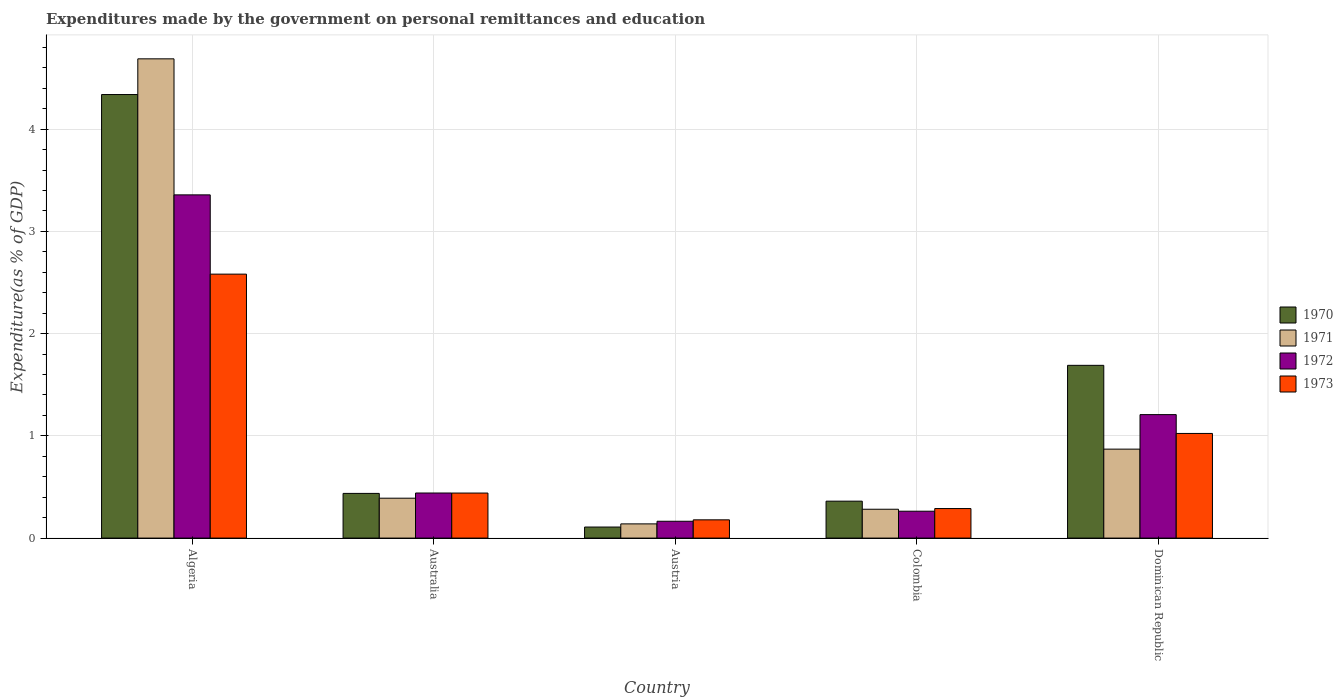Are the number of bars per tick equal to the number of legend labels?
Your answer should be very brief. Yes. How many bars are there on the 3rd tick from the left?
Offer a terse response. 4. How many bars are there on the 2nd tick from the right?
Offer a very short reply. 4. What is the label of the 5th group of bars from the left?
Make the answer very short. Dominican Republic. What is the expenditures made by the government on personal remittances and education in 1973 in Colombia?
Your answer should be very brief. 0.29. Across all countries, what is the maximum expenditures made by the government on personal remittances and education in 1970?
Ensure brevity in your answer.  4.34. Across all countries, what is the minimum expenditures made by the government on personal remittances and education in 1971?
Your answer should be very brief. 0.14. In which country was the expenditures made by the government on personal remittances and education in 1972 maximum?
Your answer should be very brief. Algeria. What is the total expenditures made by the government on personal remittances and education in 1972 in the graph?
Ensure brevity in your answer.  5.43. What is the difference between the expenditures made by the government on personal remittances and education in 1973 in Algeria and that in Australia?
Your answer should be compact. 2.14. What is the difference between the expenditures made by the government on personal remittances and education in 1971 in Dominican Republic and the expenditures made by the government on personal remittances and education in 1970 in Algeria?
Ensure brevity in your answer.  -3.47. What is the average expenditures made by the government on personal remittances and education in 1973 per country?
Keep it short and to the point. 0.9. What is the difference between the expenditures made by the government on personal remittances and education of/in 1972 and expenditures made by the government on personal remittances and education of/in 1970 in Colombia?
Offer a very short reply. -0.1. In how many countries, is the expenditures made by the government on personal remittances and education in 1973 greater than 0.4 %?
Your answer should be compact. 3. What is the ratio of the expenditures made by the government on personal remittances and education in 1973 in Algeria to that in Australia?
Offer a terse response. 5.86. What is the difference between the highest and the second highest expenditures made by the government on personal remittances and education in 1970?
Keep it short and to the point. -1.25. What is the difference between the highest and the lowest expenditures made by the government on personal remittances and education in 1970?
Keep it short and to the point. 4.23. In how many countries, is the expenditures made by the government on personal remittances and education in 1970 greater than the average expenditures made by the government on personal remittances and education in 1970 taken over all countries?
Offer a very short reply. 2. Is it the case that in every country, the sum of the expenditures made by the government on personal remittances and education in 1970 and expenditures made by the government on personal remittances and education in 1973 is greater than the sum of expenditures made by the government on personal remittances and education in 1971 and expenditures made by the government on personal remittances and education in 1972?
Your answer should be very brief. No. What does the 4th bar from the left in Colombia represents?
Offer a very short reply. 1973. Is it the case that in every country, the sum of the expenditures made by the government on personal remittances and education in 1973 and expenditures made by the government on personal remittances and education in 1972 is greater than the expenditures made by the government on personal remittances and education in 1970?
Your response must be concise. Yes. How many bars are there?
Ensure brevity in your answer.  20. Are all the bars in the graph horizontal?
Make the answer very short. No. How many countries are there in the graph?
Provide a succinct answer. 5. What is the difference between two consecutive major ticks on the Y-axis?
Give a very brief answer. 1. Are the values on the major ticks of Y-axis written in scientific E-notation?
Your response must be concise. No. Does the graph contain any zero values?
Provide a short and direct response. No. How many legend labels are there?
Ensure brevity in your answer.  4. How are the legend labels stacked?
Offer a terse response. Vertical. What is the title of the graph?
Provide a short and direct response. Expenditures made by the government on personal remittances and education. What is the label or title of the Y-axis?
Your answer should be compact. Expenditure(as % of GDP). What is the Expenditure(as % of GDP) of 1970 in Algeria?
Provide a succinct answer. 4.34. What is the Expenditure(as % of GDP) in 1971 in Algeria?
Ensure brevity in your answer.  4.69. What is the Expenditure(as % of GDP) in 1972 in Algeria?
Provide a short and direct response. 3.36. What is the Expenditure(as % of GDP) in 1973 in Algeria?
Keep it short and to the point. 2.58. What is the Expenditure(as % of GDP) of 1970 in Australia?
Offer a terse response. 0.44. What is the Expenditure(as % of GDP) in 1971 in Australia?
Your answer should be compact. 0.39. What is the Expenditure(as % of GDP) in 1972 in Australia?
Provide a succinct answer. 0.44. What is the Expenditure(as % of GDP) of 1973 in Australia?
Your answer should be very brief. 0.44. What is the Expenditure(as % of GDP) in 1970 in Austria?
Offer a very short reply. 0.11. What is the Expenditure(as % of GDP) of 1971 in Austria?
Make the answer very short. 0.14. What is the Expenditure(as % of GDP) in 1972 in Austria?
Make the answer very short. 0.16. What is the Expenditure(as % of GDP) in 1973 in Austria?
Provide a short and direct response. 0.18. What is the Expenditure(as % of GDP) of 1970 in Colombia?
Offer a terse response. 0.36. What is the Expenditure(as % of GDP) of 1971 in Colombia?
Your answer should be very brief. 0.28. What is the Expenditure(as % of GDP) of 1972 in Colombia?
Ensure brevity in your answer.  0.26. What is the Expenditure(as % of GDP) in 1973 in Colombia?
Your response must be concise. 0.29. What is the Expenditure(as % of GDP) in 1970 in Dominican Republic?
Provide a succinct answer. 1.69. What is the Expenditure(as % of GDP) of 1971 in Dominican Republic?
Your response must be concise. 0.87. What is the Expenditure(as % of GDP) in 1972 in Dominican Republic?
Ensure brevity in your answer.  1.21. What is the Expenditure(as % of GDP) of 1973 in Dominican Republic?
Your answer should be very brief. 1.02. Across all countries, what is the maximum Expenditure(as % of GDP) in 1970?
Your response must be concise. 4.34. Across all countries, what is the maximum Expenditure(as % of GDP) in 1971?
Your answer should be very brief. 4.69. Across all countries, what is the maximum Expenditure(as % of GDP) of 1972?
Your response must be concise. 3.36. Across all countries, what is the maximum Expenditure(as % of GDP) in 1973?
Keep it short and to the point. 2.58. Across all countries, what is the minimum Expenditure(as % of GDP) of 1970?
Ensure brevity in your answer.  0.11. Across all countries, what is the minimum Expenditure(as % of GDP) of 1971?
Give a very brief answer. 0.14. Across all countries, what is the minimum Expenditure(as % of GDP) of 1972?
Ensure brevity in your answer.  0.16. Across all countries, what is the minimum Expenditure(as % of GDP) in 1973?
Make the answer very short. 0.18. What is the total Expenditure(as % of GDP) in 1970 in the graph?
Your answer should be very brief. 6.93. What is the total Expenditure(as % of GDP) of 1971 in the graph?
Offer a very short reply. 6.37. What is the total Expenditure(as % of GDP) of 1972 in the graph?
Your response must be concise. 5.43. What is the total Expenditure(as % of GDP) of 1973 in the graph?
Provide a short and direct response. 4.51. What is the difference between the Expenditure(as % of GDP) of 1970 in Algeria and that in Australia?
Make the answer very short. 3.9. What is the difference between the Expenditure(as % of GDP) in 1971 in Algeria and that in Australia?
Offer a terse response. 4.3. What is the difference between the Expenditure(as % of GDP) of 1972 in Algeria and that in Australia?
Give a very brief answer. 2.92. What is the difference between the Expenditure(as % of GDP) of 1973 in Algeria and that in Australia?
Offer a terse response. 2.14. What is the difference between the Expenditure(as % of GDP) of 1970 in Algeria and that in Austria?
Your answer should be compact. 4.23. What is the difference between the Expenditure(as % of GDP) of 1971 in Algeria and that in Austria?
Your answer should be very brief. 4.55. What is the difference between the Expenditure(as % of GDP) in 1972 in Algeria and that in Austria?
Offer a terse response. 3.19. What is the difference between the Expenditure(as % of GDP) of 1973 in Algeria and that in Austria?
Your answer should be compact. 2.4. What is the difference between the Expenditure(as % of GDP) in 1970 in Algeria and that in Colombia?
Keep it short and to the point. 3.98. What is the difference between the Expenditure(as % of GDP) in 1971 in Algeria and that in Colombia?
Ensure brevity in your answer.  4.41. What is the difference between the Expenditure(as % of GDP) of 1972 in Algeria and that in Colombia?
Your answer should be very brief. 3.09. What is the difference between the Expenditure(as % of GDP) of 1973 in Algeria and that in Colombia?
Your answer should be compact. 2.29. What is the difference between the Expenditure(as % of GDP) of 1970 in Algeria and that in Dominican Republic?
Provide a succinct answer. 2.65. What is the difference between the Expenditure(as % of GDP) in 1971 in Algeria and that in Dominican Republic?
Offer a terse response. 3.82. What is the difference between the Expenditure(as % of GDP) in 1972 in Algeria and that in Dominican Republic?
Provide a succinct answer. 2.15. What is the difference between the Expenditure(as % of GDP) of 1973 in Algeria and that in Dominican Republic?
Your answer should be compact. 1.56. What is the difference between the Expenditure(as % of GDP) in 1970 in Australia and that in Austria?
Provide a short and direct response. 0.33. What is the difference between the Expenditure(as % of GDP) in 1971 in Australia and that in Austria?
Offer a very short reply. 0.25. What is the difference between the Expenditure(as % of GDP) in 1972 in Australia and that in Austria?
Offer a very short reply. 0.28. What is the difference between the Expenditure(as % of GDP) of 1973 in Australia and that in Austria?
Keep it short and to the point. 0.26. What is the difference between the Expenditure(as % of GDP) of 1970 in Australia and that in Colombia?
Provide a short and direct response. 0.08. What is the difference between the Expenditure(as % of GDP) of 1971 in Australia and that in Colombia?
Make the answer very short. 0.11. What is the difference between the Expenditure(as % of GDP) of 1972 in Australia and that in Colombia?
Provide a succinct answer. 0.18. What is the difference between the Expenditure(as % of GDP) of 1973 in Australia and that in Colombia?
Keep it short and to the point. 0.15. What is the difference between the Expenditure(as % of GDP) in 1970 in Australia and that in Dominican Republic?
Your answer should be very brief. -1.25. What is the difference between the Expenditure(as % of GDP) in 1971 in Australia and that in Dominican Republic?
Your response must be concise. -0.48. What is the difference between the Expenditure(as % of GDP) of 1972 in Australia and that in Dominican Republic?
Offer a very short reply. -0.77. What is the difference between the Expenditure(as % of GDP) of 1973 in Australia and that in Dominican Republic?
Make the answer very short. -0.58. What is the difference between the Expenditure(as % of GDP) of 1970 in Austria and that in Colombia?
Your answer should be compact. -0.25. What is the difference between the Expenditure(as % of GDP) in 1971 in Austria and that in Colombia?
Offer a terse response. -0.14. What is the difference between the Expenditure(as % of GDP) of 1972 in Austria and that in Colombia?
Offer a terse response. -0.1. What is the difference between the Expenditure(as % of GDP) of 1973 in Austria and that in Colombia?
Your response must be concise. -0.11. What is the difference between the Expenditure(as % of GDP) of 1970 in Austria and that in Dominican Republic?
Your answer should be very brief. -1.58. What is the difference between the Expenditure(as % of GDP) of 1971 in Austria and that in Dominican Republic?
Offer a very short reply. -0.73. What is the difference between the Expenditure(as % of GDP) in 1972 in Austria and that in Dominican Republic?
Your response must be concise. -1.04. What is the difference between the Expenditure(as % of GDP) of 1973 in Austria and that in Dominican Republic?
Provide a short and direct response. -0.84. What is the difference between the Expenditure(as % of GDP) of 1970 in Colombia and that in Dominican Republic?
Offer a terse response. -1.33. What is the difference between the Expenditure(as % of GDP) in 1971 in Colombia and that in Dominican Republic?
Your answer should be very brief. -0.59. What is the difference between the Expenditure(as % of GDP) in 1972 in Colombia and that in Dominican Republic?
Provide a succinct answer. -0.94. What is the difference between the Expenditure(as % of GDP) in 1973 in Colombia and that in Dominican Republic?
Keep it short and to the point. -0.73. What is the difference between the Expenditure(as % of GDP) of 1970 in Algeria and the Expenditure(as % of GDP) of 1971 in Australia?
Offer a terse response. 3.95. What is the difference between the Expenditure(as % of GDP) of 1970 in Algeria and the Expenditure(as % of GDP) of 1972 in Australia?
Your answer should be compact. 3.9. What is the difference between the Expenditure(as % of GDP) in 1970 in Algeria and the Expenditure(as % of GDP) in 1973 in Australia?
Make the answer very short. 3.9. What is the difference between the Expenditure(as % of GDP) of 1971 in Algeria and the Expenditure(as % of GDP) of 1972 in Australia?
Offer a very short reply. 4.25. What is the difference between the Expenditure(as % of GDP) of 1971 in Algeria and the Expenditure(as % of GDP) of 1973 in Australia?
Provide a succinct answer. 4.25. What is the difference between the Expenditure(as % of GDP) of 1972 in Algeria and the Expenditure(as % of GDP) of 1973 in Australia?
Your response must be concise. 2.92. What is the difference between the Expenditure(as % of GDP) in 1970 in Algeria and the Expenditure(as % of GDP) in 1971 in Austria?
Give a very brief answer. 4.2. What is the difference between the Expenditure(as % of GDP) in 1970 in Algeria and the Expenditure(as % of GDP) in 1972 in Austria?
Your answer should be compact. 4.17. What is the difference between the Expenditure(as % of GDP) in 1970 in Algeria and the Expenditure(as % of GDP) in 1973 in Austria?
Ensure brevity in your answer.  4.16. What is the difference between the Expenditure(as % of GDP) in 1971 in Algeria and the Expenditure(as % of GDP) in 1972 in Austria?
Offer a terse response. 4.52. What is the difference between the Expenditure(as % of GDP) of 1971 in Algeria and the Expenditure(as % of GDP) of 1973 in Austria?
Ensure brevity in your answer.  4.51. What is the difference between the Expenditure(as % of GDP) in 1972 in Algeria and the Expenditure(as % of GDP) in 1973 in Austria?
Give a very brief answer. 3.18. What is the difference between the Expenditure(as % of GDP) of 1970 in Algeria and the Expenditure(as % of GDP) of 1971 in Colombia?
Your answer should be very brief. 4.06. What is the difference between the Expenditure(as % of GDP) of 1970 in Algeria and the Expenditure(as % of GDP) of 1972 in Colombia?
Make the answer very short. 4.08. What is the difference between the Expenditure(as % of GDP) of 1970 in Algeria and the Expenditure(as % of GDP) of 1973 in Colombia?
Your response must be concise. 4.05. What is the difference between the Expenditure(as % of GDP) of 1971 in Algeria and the Expenditure(as % of GDP) of 1972 in Colombia?
Ensure brevity in your answer.  4.42. What is the difference between the Expenditure(as % of GDP) in 1971 in Algeria and the Expenditure(as % of GDP) in 1973 in Colombia?
Your answer should be very brief. 4.4. What is the difference between the Expenditure(as % of GDP) in 1972 in Algeria and the Expenditure(as % of GDP) in 1973 in Colombia?
Your response must be concise. 3.07. What is the difference between the Expenditure(as % of GDP) of 1970 in Algeria and the Expenditure(as % of GDP) of 1971 in Dominican Republic?
Keep it short and to the point. 3.47. What is the difference between the Expenditure(as % of GDP) of 1970 in Algeria and the Expenditure(as % of GDP) of 1972 in Dominican Republic?
Give a very brief answer. 3.13. What is the difference between the Expenditure(as % of GDP) in 1970 in Algeria and the Expenditure(as % of GDP) in 1973 in Dominican Republic?
Make the answer very short. 3.31. What is the difference between the Expenditure(as % of GDP) of 1971 in Algeria and the Expenditure(as % of GDP) of 1972 in Dominican Republic?
Provide a short and direct response. 3.48. What is the difference between the Expenditure(as % of GDP) in 1971 in Algeria and the Expenditure(as % of GDP) in 1973 in Dominican Republic?
Make the answer very short. 3.66. What is the difference between the Expenditure(as % of GDP) in 1972 in Algeria and the Expenditure(as % of GDP) in 1973 in Dominican Republic?
Offer a terse response. 2.33. What is the difference between the Expenditure(as % of GDP) in 1970 in Australia and the Expenditure(as % of GDP) in 1971 in Austria?
Offer a terse response. 0.3. What is the difference between the Expenditure(as % of GDP) in 1970 in Australia and the Expenditure(as % of GDP) in 1972 in Austria?
Your answer should be compact. 0.27. What is the difference between the Expenditure(as % of GDP) of 1970 in Australia and the Expenditure(as % of GDP) of 1973 in Austria?
Offer a very short reply. 0.26. What is the difference between the Expenditure(as % of GDP) in 1971 in Australia and the Expenditure(as % of GDP) in 1972 in Austria?
Your answer should be compact. 0.23. What is the difference between the Expenditure(as % of GDP) in 1971 in Australia and the Expenditure(as % of GDP) in 1973 in Austria?
Offer a terse response. 0.21. What is the difference between the Expenditure(as % of GDP) of 1972 in Australia and the Expenditure(as % of GDP) of 1973 in Austria?
Offer a very short reply. 0.26. What is the difference between the Expenditure(as % of GDP) in 1970 in Australia and the Expenditure(as % of GDP) in 1971 in Colombia?
Keep it short and to the point. 0.15. What is the difference between the Expenditure(as % of GDP) in 1970 in Australia and the Expenditure(as % of GDP) in 1972 in Colombia?
Your answer should be compact. 0.17. What is the difference between the Expenditure(as % of GDP) in 1970 in Australia and the Expenditure(as % of GDP) in 1973 in Colombia?
Provide a succinct answer. 0.15. What is the difference between the Expenditure(as % of GDP) of 1971 in Australia and the Expenditure(as % of GDP) of 1972 in Colombia?
Give a very brief answer. 0.13. What is the difference between the Expenditure(as % of GDP) in 1971 in Australia and the Expenditure(as % of GDP) in 1973 in Colombia?
Make the answer very short. 0.1. What is the difference between the Expenditure(as % of GDP) in 1972 in Australia and the Expenditure(as % of GDP) in 1973 in Colombia?
Offer a very short reply. 0.15. What is the difference between the Expenditure(as % of GDP) in 1970 in Australia and the Expenditure(as % of GDP) in 1971 in Dominican Republic?
Your answer should be compact. -0.43. What is the difference between the Expenditure(as % of GDP) in 1970 in Australia and the Expenditure(as % of GDP) in 1972 in Dominican Republic?
Give a very brief answer. -0.77. What is the difference between the Expenditure(as % of GDP) in 1970 in Australia and the Expenditure(as % of GDP) in 1973 in Dominican Republic?
Give a very brief answer. -0.59. What is the difference between the Expenditure(as % of GDP) of 1971 in Australia and the Expenditure(as % of GDP) of 1972 in Dominican Republic?
Your answer should be compact. -0.82. What is the difference between the Expenditure(as % of GDP) in 1971 in Australia and the Expenditure(as % of GDP) in 1973 in Dominican Republic?
Give a very brief answer. -0.63. What is the difference between the Expenditure(as % of GDP) of 1972 in Australia and the Expenditure(as % of GDP) of 1973 in Dominican Republic?
Ensure brevity in your answer.  -0.58. What is the difference between the Expenditure(as % of GDP) in 1970 in Austria and the Expenditure(as % of GDP) in 1971 in Colombia?
Provide a short and direct response. -0.17. What is the difference between the Expenditure(as % of GDP) of 1970 in Austria and the Expenditure(as % of GDP) of 1972 in Colombia?
Offer a terse response. -0.15. What is the difference between the Expenditure(as % of GDP) in 1970 in Austria and the Expenditure(as % of GDP) in 1973 in Colombia?
Make the answer very short. -0.18. What is the difference between the Expenditure(as % of GDP) in 1971 in Austria and the Expenditure(as % of GDP) in 1972 in Colombia?
Keep it short and to the point. -0.12. What is the difference between the Expenditure(as % of GDP) of 1971 in Austria and the Expenditure(as % of GDP) of 1973 in Colombia?
Give a very brief answer. -0.15. What is the difference between the Expenditure(as % of GDP) of 1972 in Austria and the Expenditure(as % of GDP) of 1973 in Colombia?
Your response must be concise. -0.12. What is the difference between the Expenditure(as % of GDP) in 1970 in Austria and the Expenditure(as % of GDP) in 1971 in Dominican Republic?
Make the answer very short. -0.76. What is the difference between the Expenditure(as % of GDP) of 1970 in Austria and the Expenditure(as % of GDP) of 1972 in Dominican Republic?
Offer a very short reply. -1.1. What is the difference between the Expenditure(as % of GDP) in 1970 in Austria and the Expenditure(as % of GDP) in 1973 in Dominican Republic?
Offer a very short reply. -0.92. What is the difference between the Expenditure(as % of GDP) in 1971 in Austria and the Expenditure(as % of GDP) in 1972 in Dominican Republic?
Your answer should be compact. -1.07. What is the difference between the Expenditure(as % of GDP) of 1971 in Austria and the Expenditure(as % of GDP) of 1973 in Dominican Republic?
Your answer should be compact. -0.88. What is the difference between the Expenditure(as % of GDP) in 1972 in Austria and the Expenditure(as % of GDP) in 1973 in Dominican Republic?
Your answer should be compact. -0.86. What is the difference between the Expenditure(as % of GDP) in 1970 in Colombia and the Expenditure(as % of GDP) in 1971 in Dominican Republic?
Provide a succinct answer. -0.51. What is the difference between the Expenditure(as % of GDP) in 1970 in Colombia and the Expenditure(as % of GDP) in 1972 in Dominican Republic?
Offer a terse response. -0.85. What is the difference between the Expenditure(as % of GDP) in 1970 in Colombia and the Expenditure(as % of GDP) in 1973 in Dominican Republic?
Your answer should be compact. -0.66. What is the difference between the Expenditure(as % of GDP) of 1971 in Colombia and the Expenditure(as % of GDP) of 1972 in Dominican Republic?
Your answer should be very brief. -0.93. What is the difference between the Expenditure(as % of GDP) of 1971 in Colombia and the Expenditure(as % of GDP) of 1973 in Dominican Republic?
Your answer should be very brief. -0.74. What is the difference between the Expenditure(as % of GDP) in 1972 in Colombia and the Expenditure(as % of GDP) in 1973 in Dominican Republic?
Give a very brief answer. -0.76. What is the average Expenditure(as % of GDP) in 1970 per country?
Give a very brief answer. 1.39. What is the average Expenditure(as % of GDP) of 1971 per country?
Your answer should be compact. 1.27. What is the average Expenditure(as % of GDP) of 1972 per country?
Offer a terse response. 1.09. What is the average Expenditure(as % of GDP) of 1973 per country?
Your answer should be compact. 0.9. What is the difference between the Expenditure(as % of GDP) in 1970 and Expenditure(as % of GDP) in 1971 in Algeria?
Your answer should be very brief. -0.35. What is the difference between the Expenditure(as % of GDP) of 1970 and Expenditure(as % of GDP) of 1972 in Algeria?
Make the answer very short. 0.98. What is the difference between the Expenditure(as % of GDP) in 1970 and Expenditure(as % of GDP) in 1973 in Algeria?
Your answer should be very brief. 1.76. What is the difference between the Expenditure(as % of GDP) in 1971 and Expenditure(as % of GDP) in 1972 in Algeria?
Your answer should be very brief. 1.33. What is the difference between the Expenditure(as % of GDP) in 1971 and Expenditure(as % of GDP) in 1973 in Algeria?
Your response must be concise. 2.11. What is the difference between the Expenditure(as % of GDP) in 1972 and Expenditure(as % of GDP) in 1973 in Algeria?
Your response must be concise. 0.78. What is the difference between the Expenditure(as % of GDP) in 1970 and Expenditure(as % of GDP) in 1971 in Australia?
Your answer should be very brief. 0.05. What is the difference between the Expenditure(as % of GDP) in 1970 and Expenditure(as % of GDP) in 1972 in Australia?
Provide a succinct answer. -0. What is the difference between the Expenditure(as % of GDP) of 1970 and Expenditure(as % of GDP) of 1973 in Australia?
Offer a terse response. -0. What is the difference between the Expenditure(as % of GDP) in 1971 and Expenditure(as % of GDP) in 1972 in Australia?
Offer a terse response. -0.05. What is the difference between the Expenditure(as % of GDP) of 1971 and Expenditure(as % of GDP) of 1973 in Australia?
Your answer should be compact. -0.05. What is the difference between the Expenditure(as % of GDP) of 1972 and Expenditure(as % of GDP) of 1973 in Australia?
Provide a succinct answer. 0. What is the difference between the Expenditure(as % of GDP) in 1970 and Expenditure(as % of GDP) in 1971 in Austria?
Make the answer very short. -0.03. What is the difference between the Expenditure(as % of GDP) of 1970 and Expenditure(as % of GDP) of 1972 in Austria?
Your answer should be compact. -0.06. What is the difference between the Expenditure(as % of GDP) of 1970 and Expenditure(as % of GDP) of 1973 in Austria?
Give a very brief answer. -0.07. What is the difference between the Expenditure(as % of GDP) in 1971 and Expenditure(as % of GDP) in 1972 in Austria?
Offer a terse response. -0.03. What is the difference between the Expenditure(as % of GDP) in 1971 and Expenditure(as % of GDP) in 1973 in Austria?
Give a very brief answer. -0.04. What is the difference between the Expenditure(as % of GDP) of 1972 and Expenditure(as % of GDP) of 1973 in Austria?
Your response must be concise. -0.01. What is the difference between the Expenditure(as % of GDP) of 1970 and Expenditure(as % of GDP) of 1971 in Colombia?
Make the answer very short. 0.08. What is the difference between the Expenditure(as % of GDP) in 1970 and Expenditure(as % of GDP) in 1972 in Colombia?
Your response must be concise. 0.1. What is the difference between the Expenditure(as % of GDP) in 1970 and Expenditure(as % of GDP) in 1973 in Colombia?
Offer a terse response. 0.07. What is the difference between the Expenditure(as % of GDP) of 1971 and Expenditure(as % of GDP) of 1972 in Colombia?
Your answer should be very brief. 0.02. What is the difference between the Expenditure(as % of GDP) in 1971 and Expenditure(as % of GDP) in 1973 in Colombia?
Provide a succinct answer. -0.01. What is the difference between the Expenditure(as % of GDP) of 1972 and Expenditure(as % of GDP) of 1973 in Colombia?
Offer a very short reply. -0.03. What is the difference between the Expenditure(as % of GDP) in 1970 and Expenditure(as % of GDP) in 1971 in Dominican Republic?
Offer a terse response. 0.82. What is the difference between the Expenditure(as % of GDP) of 1970 and Expenditure(as % of GDP) of 1972 in Dominican Republic?
Provide a short and direct response. 0.48. What is the difference between the Expenditure(as % of GDP) of 1970 and Expenditure(as % of GDP) of 1973 in Dominican Republic?
Your answer should be very brief. 0.67. What is the difference between the Expenditure(as % of GDP) of 1971 and Expenditure(as % of GDP) of 1972 in Dominican Republic?
Make the answer very short. -0.34. What is the difference between the Expenditure(as % of GDP) of 1971 and Expenditure(as % of GDP) of 1973 in Dominican Republic?
Ensure brevity in your answer.  -0.15. What is the difference between the Expenditure(as % of GDP) of 1972 and Expenditure(as % of GDP) of 1973 in Dominican Republic?
Provide a short and direct response. 0.18. What is the ratio of the Expenditure(as % of GDP) of 1970 in Algeria to that in Australia?
Your answer should be very brief. 9.92. What is the ratio of the Expenditure(as % of GDP) of 1971 in Algeria to that in Australia?
Make the answer very short. 12.01. What is the ratio of the Expenditure(as % of GDP) of 1972 in Algeria to that in Australia?
Your response must be concise. 7.61. What is the ratio of the Expenditure(as % of GDP) in 1973 in Algeria to that in Australia?
Ensure brevity in your answer.  5.86. What is the ratio of the Expenditure(as % of GDP) of 1970 in Algeria to that in Austria?
Offer a very short reply. 40.14. What is the ratio of the Expenditure(as % of GDP) of 1971 in Algeria to that in Austria?
Your answer should be compact. 33.73. What is the ratio of the Expenditure(as % of GDP) of 1972 in Algeria to that in Austria?
Your answer should be very brief. 20.38. What is the ratio of the Expenditure(as % of GDP) in 1973 in Algeria to that in Austria?
Make the answer very short. 14.45. What is the ratio of the Expenditure(as % of GDP) of 1970 in Algeria to that in Colombia?
Offer a very short reply. 12.01. What is the ratio of the Expenditure(as % of GDP) of 1971 in Algeria to that in Colombia?
Make the answer very short. 16.61. What is the ratio of the Expenditure(as % of GDP) in 1972 in Algeria to that in Colombia?
Ensure brevity in your answer.  12.77. What is the ratio of the Expenditure(as % of GDP) in 1973 in Algeria to that in Colombia?
Your answer should be very brief. 8.94. What is the ratio of the Expenditure(as % of GDP) in 1970 in Algeria to that in Dominican Republic?
Make the answer very short. 2.57. What is the ratio of the Expenditure(as % of GDP) of 1971 in Algeria to that in Dominican Republic?
Keep it short and to the point. 5.39. What is the ratio of the Expenditure(as % of GDP) of 1972 in Algeria to that in Dominican Republic?
Make the answer very short. 2.78. What is the ratio of the Expenditure(as % of GDP) of 1973 in Algeria to that in Dominican Republic?
Your response must be concise. 2.52. What is the ratio of the Expenditure(as % of GDP) in 1970 in Australia to that in Austria?
Ensure brevity in your answer.  4.04. What is the ratio of the Expenditure(as % of GDP) of 1971 in Australia to that in Austria?
Your response must be concise. 2.81. What is the ratio of the Expenditure(as % of GDP) of 1972 in Australia to that in Austria?
Offer a terse response. 2.68. What is the ratio of the Expenditure(as % of GDP) of 1973 in Australia to that in Austria?
Provide a succinct answer. 2.47. What is the ratio of the Expenditure(as % of GDP) of 1970 in Australia to that in Colombia?
Offer a terse response. 1.21. What is the ratio of the Expenditure(as % of GDP) of 1971 in Australia to that in Colombia?
Your answer should be very brief. 1.38. What is the ratio of the Expenditure(as % of GDP) of 1972 in Australia to that in Colombia?
Your answer should be very brief. 1.68. What is the ratio of the Expenditure(as % of GDP) of 1973 in Australia to that in Colombia?
Provide a succinct answer. 1.52. What is the ratio of the Expenditure(as % of GDP) of 1970 in Australia to that in Dominican Republic?
Give a very brief answer. 0.26. What is the ratio of the Expenditure(as % of GDP) in 1971 in Australia to that in Dominican Republic?
Ensure brevity in your answer.  0.45. What is the ratio of the Expenditure(as % of GDP) of 1972 in Australia to that in Dominican Republic?
Give a very brief answer. 0.37. What is the ratio of the Expenditure(as % of GDP) in 1973 in Australia to that in Dominican Republic?
Your answer should be compact. 0.43. What is the ratio of the Expenditure(as % of GDP) in 1970 in Austria to that in Colombia?
Provide a succinct answer. 0.3. What is the ratio of the Expenditure(as % of GDP) of 1971 in Austria to that in Colombia?
Provide a succinct answer. 0.49. What is the ratio of the Expenditure(as % of GDP) in 1972 in Austria to that in Colombia?
Provide a succinct answer. 0.63. What is the ratio of the Expenditure(as % of GDP) of 1973 in Austria to that in Colombia?
Keep it short and to the point. 0.62. What is the ratio of the Expenditure(as % of GDP) of 1970 in Austria to that in Dominican Republic?
Your answer should be very brief. 0.06. What is the ratio of the Expenditure(as % of GDP) in 1971 in Austria to that in Dominican Republic?
Keep it short and to the point. 0.16. What is the ratio of the Expenditure(as % of GDP) of 1972 in Austria to that in Dominican Republic?
Your answer should be compact. 0.14. What is the ratio of the Expenditure(as % of GDP) of 1973 in Austria to that in Dominican Republic?
Provide a succinct answer. 0.17. What is the ratio of the Expenditure(as % of GDP) of 1970 in Colombia to that in Dominican Republic?
Keep it short and to the point. 0.21. What is the ratio of the Expenditure(as % of GDP) of 1971 in Colombia to that in Dominican Republic?
Make the answer very short. 0.32. What is the ratio of the Expenditure(as % of GDP) of 1972 in Colombia to that in Dominican Republic?
Offer a terse response. 0.22. What is the ratio of the Expenditure(as % of GDP) in 1973 in Colombia to that in Dominican Republic?
Ensure brevity in your answer.  0.28. What is the difference between the highest and the second highest Expenditure(as % of GDP) of 1970?
Give a very brief answer. 2.65. What is the difference between the highest and the second highest Expenditure(as % of GDP) in 1971?
Offer a very short reply. 3.82. What is the difference between the highest and the second highest Expenditure(as % of GDP) in 1972?
Provide a short and direct response. 2.15. What is the difference between the highest and the second highest Expenditure(as % of GDP) in 1973?
Your response must be concise. 1.56. What is the difference between the highest and the lowest Expenditure(as % of GDP) in 1970?
Give a very brief answer. 4.23. What is the difference between the highest and the lowest Expenditure(as % of GDP) in 1971?
Keep it short and to the point. 4.55. What is the difference between the highest and the lowest Expenditure(as % of GDP) in 1972?
Your answer should be very brief. 3.19. What is the difference between the highest and the lowest Expenditure(as % of GDP) in 1973?
Offer a terse response. 2.4. 